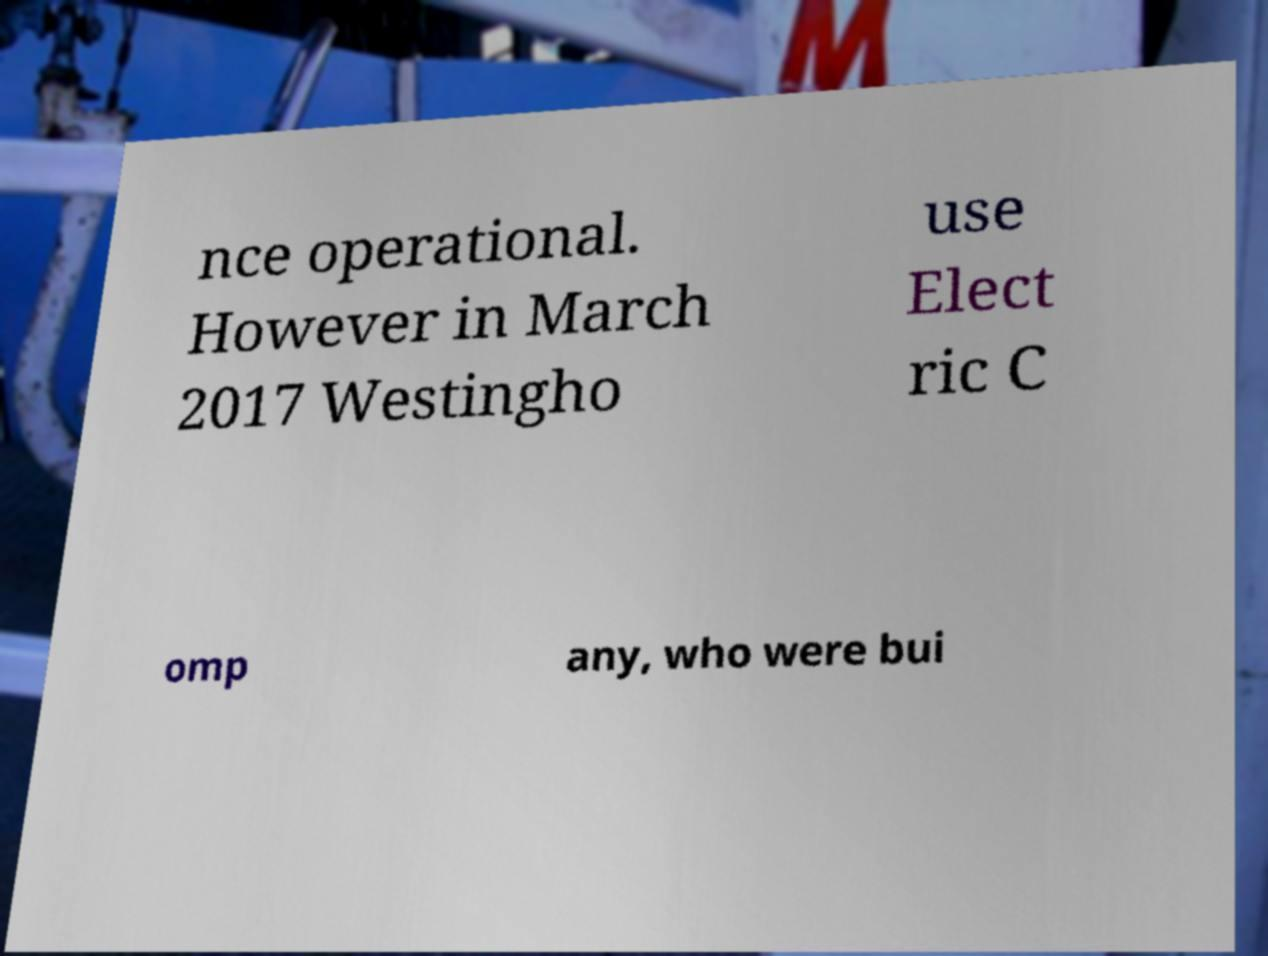Please identify and transcribe the text found in this image. nce operational. However in March 2017 Westingho use Elect ric C omp any, who were bui 